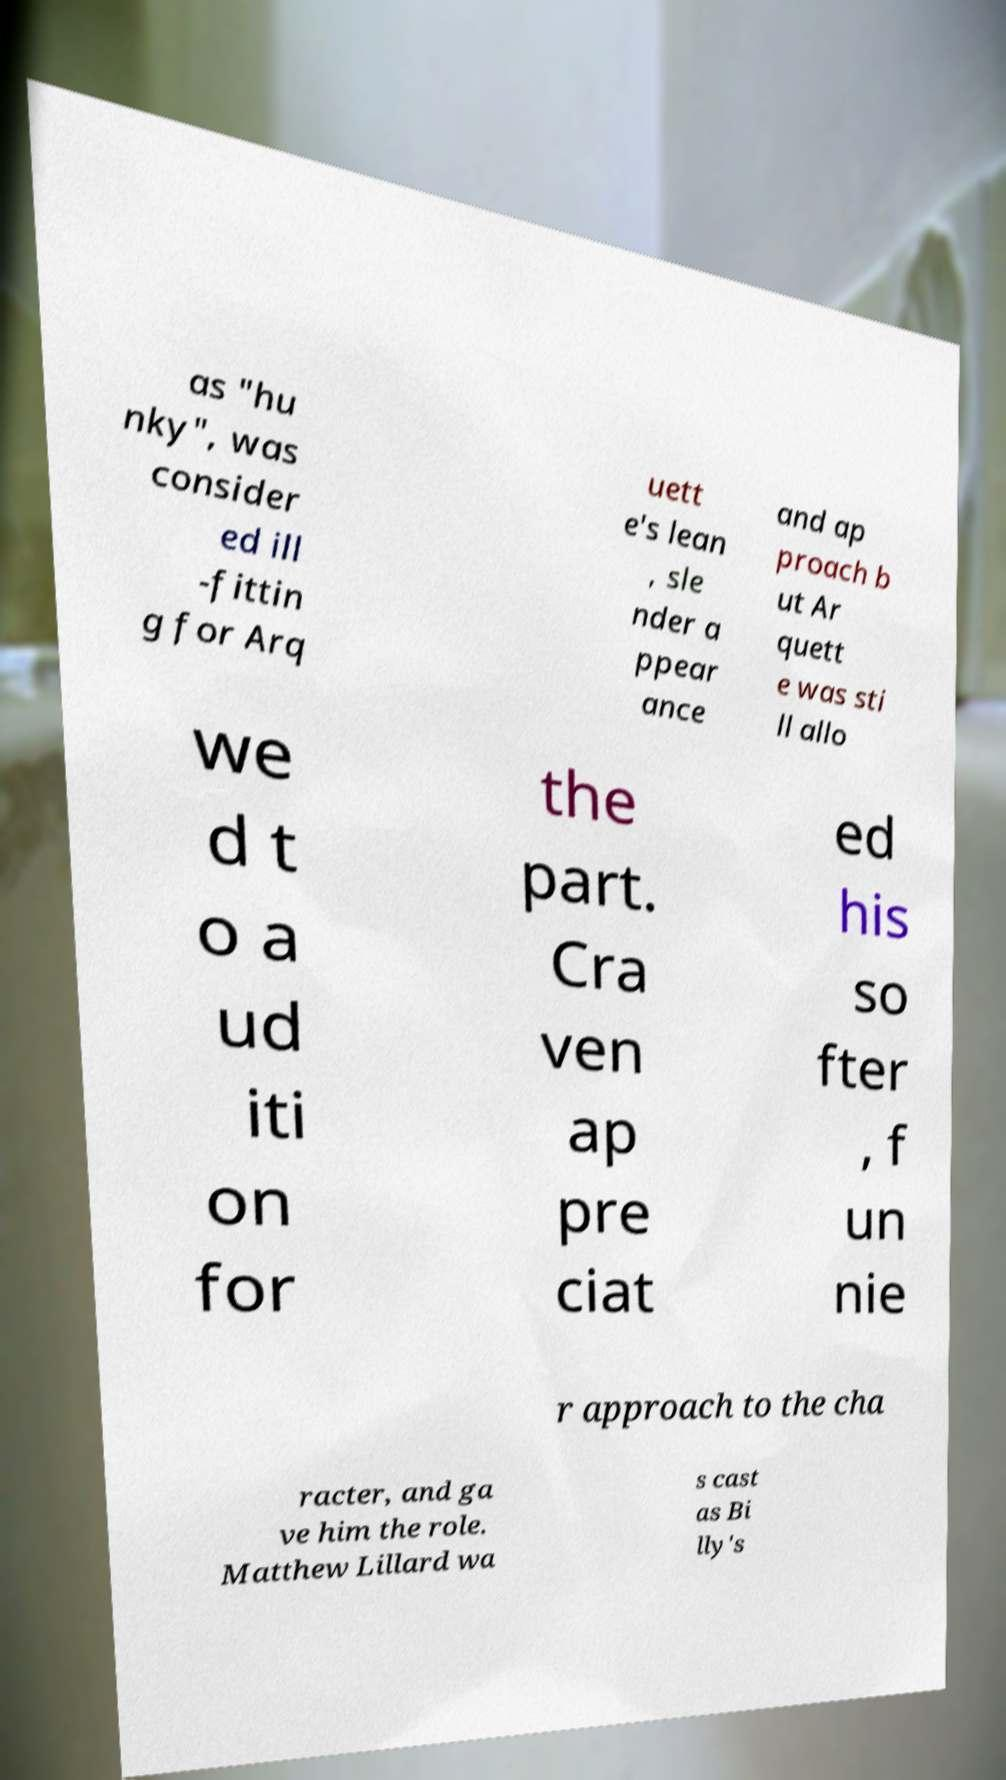I need the written content from this picture converted into text. Can you do that? as "hu nky", was consider ed ill -fittin g for Arq uett e's lean , sle nder a ppear ance and ap proach b ut Ar quett e was sti ll allo we d t o a ud iti on for the part. Cra ven ap pre ciat ed his so fter , f un nie r approach to the cha racter, and ga ve him the role. Matthew Lillard wa s cast as Bi lly's 